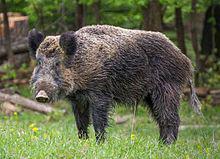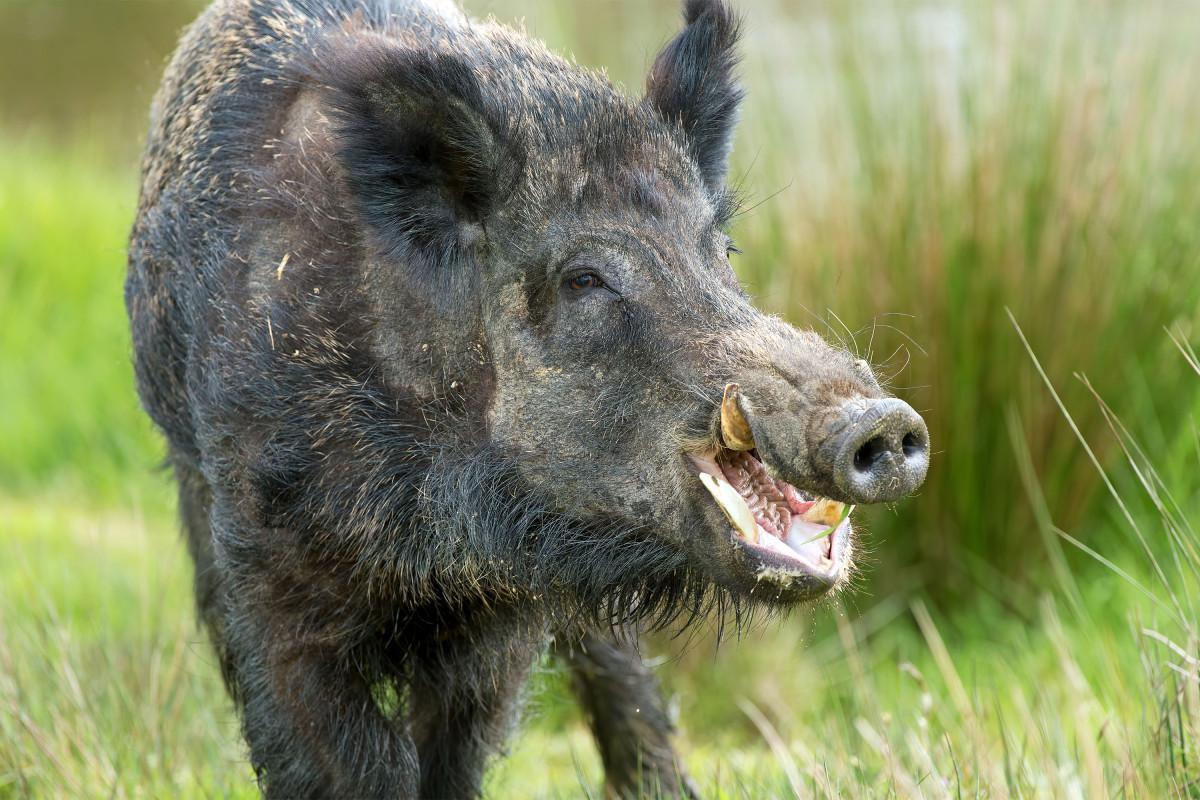The first image is the image on the left, the second image is the image on the right. Considering the images on both sides, is "A single wild pig stands in the grass in the image on the left." valid? Answer yes or no. Yes. The first image is the image on the left, the second image is the image on the right. Examine the images to the left and right. Is the description "Each image shows exactly one wild boar." accurate? Answer yes or no. Yes. 